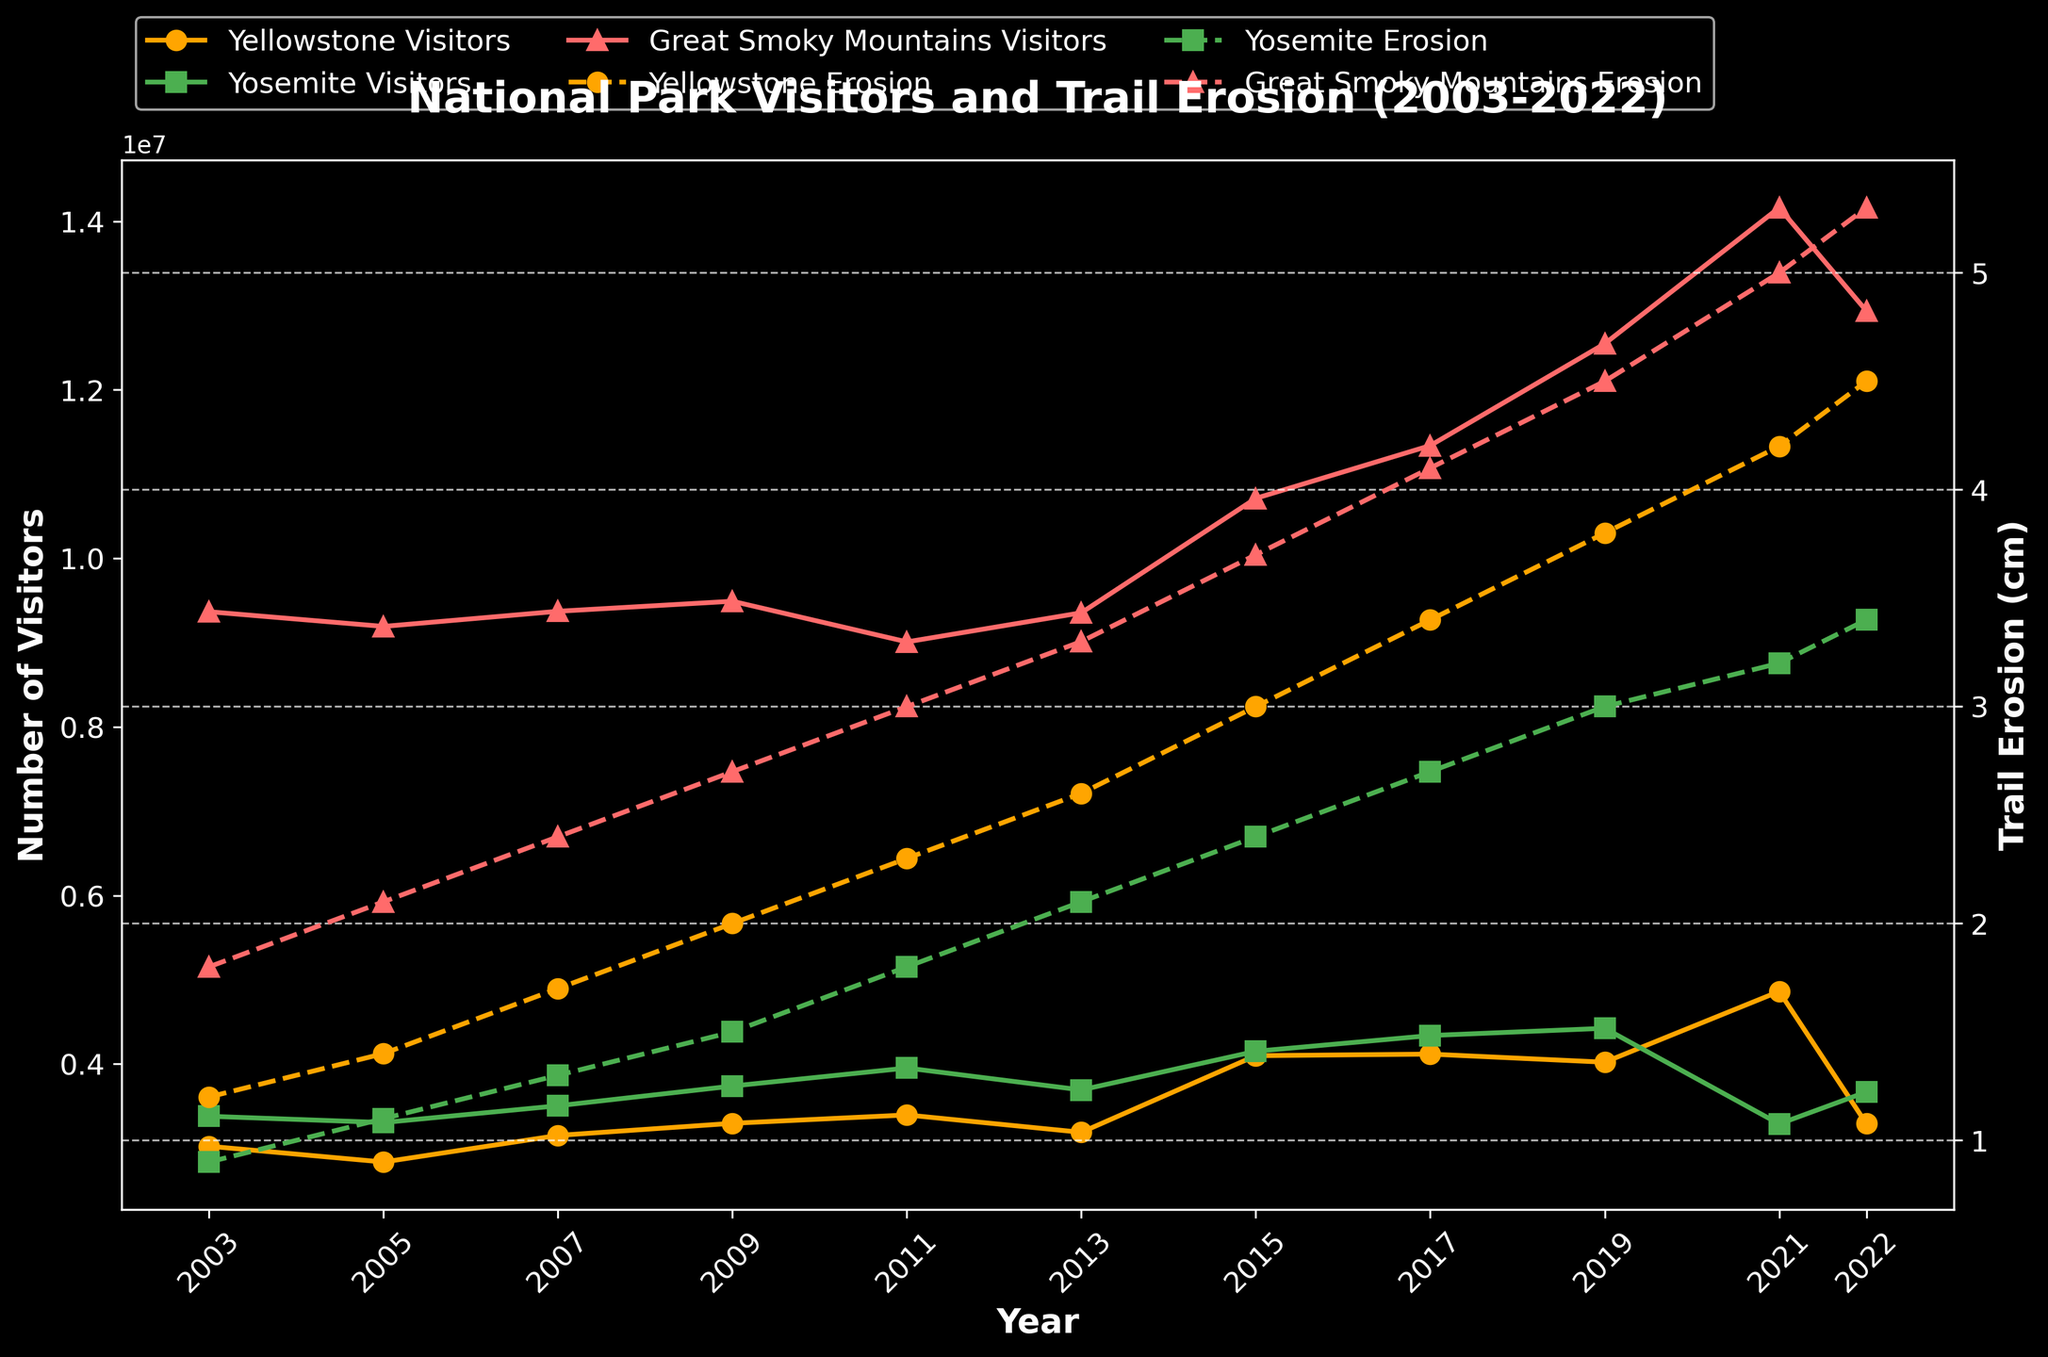Which national park had the highest number of visitors in 2021? Look for the year 2021 in the figure and compare visitor numbers for Yellowstone, Yosemite, and Great Smoky Mountains. The Great Smoky Mountains had the highest among them.
Answer: Great Smoky Mountains How much did trail erosion in Yellowstone change from 2003 to 2022? Locate the line for Yellowstone's trail erosion and compare the values at 2003 (1.2 cm) and 2022 (4.5 cm). Subtract 1.2 cm from 4.5 cm to find the change.
Answer: 3.3 cm Which park showed the greatest increase in visitor numbers over the 20 years? Look at the starting and ending points for each park's visitors. Subtract the visitor numbers in 2003 from those in 2022 for each park. Compare the increases: Yellowstone's increase from 3022830 to 3290242 (267412), Yosemite's increase from 3378664 to 3667550 (288886), and Great Smoky Mountains' increase from 9366845 to 12937633 (3570788).
Answer: Great Smoky Mountains What is the average trail erosion in Yosemite over the 20 years? Add up the Yosemite erosion values for each year and divide by the number of years. (0.9 + 1.1 + 1.3 + 1.5 + 1.8 + 2.1 + 2.4 + 2.7 + 3.0 + 3.2 + 3.4) / 11 = 2.09 cm
Answer: 2.09 cm In which year did Great Smoky Mountains see the biggest jump in visitor numbers? Look at the visitor trends for Great Smoky Mountains and identify the year with a noticeable jump. From 2019 to 2021, there is a significant increase (from 12547743 to 14161548).
Answer: 2021 Compare the trend lines for trail erosion: which park's trail erosion rate appears to be increasing the fastest? Look at the slopes of the trail erosion lines for each park. The line for Great Smoky Mountains has the steepest upward slope, suggesting its erosion rate is increasing the fastest.
Answer: Great Smoky Mountains What was the percentage increase in visitors to Yellowstone from 2015 to 2021? Find the number of visitors in 2015 and 2021. The numbers are 4097710 and 4860242 respectively. Calculate the percentage increase using ((4860242 - 4097710) / 4097710) x 100.
Answer: 18.5% Which national park had the least trail erosion in 2019? Look at the trail erosion data points for 2019. Compare erosion values: Yellowstone (3.8 cm), Yosemite (3.0 cm), Great Smoky Mountains (4.5 cm). Yosemite has the least trail erosion.
Answer: Yosemite Was there any year when Yellowstone had more visitors than Yosemite? Compare the visitor lines of Yellowstone and Yosemite year-by-year. There is no year where Yellowstone surpasses Yosemite in visitors.
Answer: No 